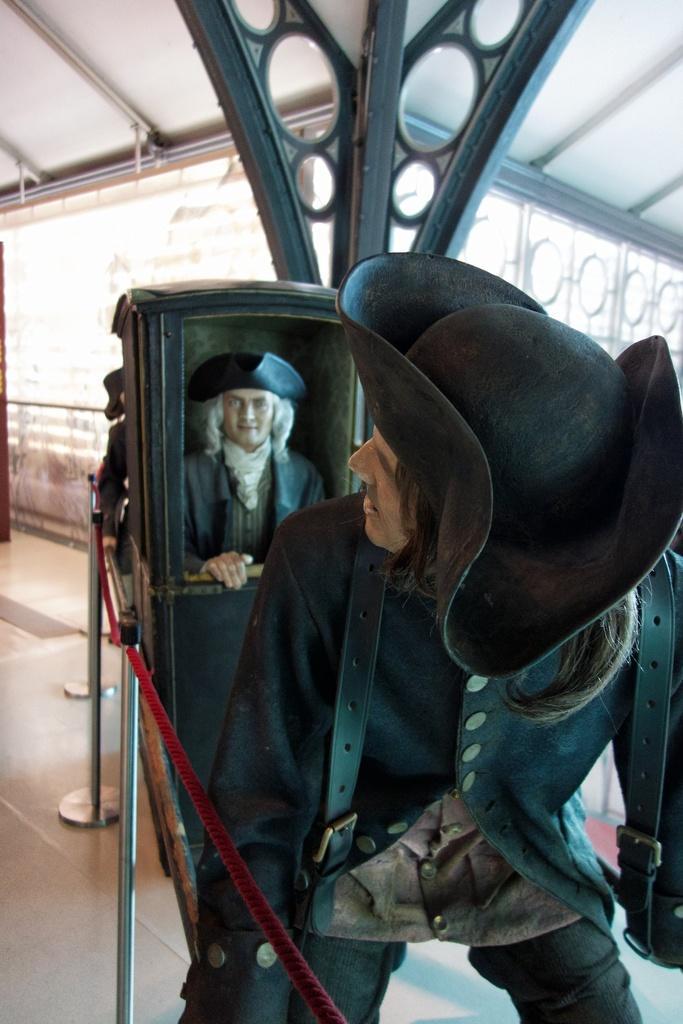Please provide a concise description of this image. In this picture there is a man who is wearing black cap, shirt and trouser. He is standing near to the box. In the box we can see a man. On the top we can see a shed. In the background we can see a white color wall. On the left we can see steel pipes with red color cloth is attached to it. 